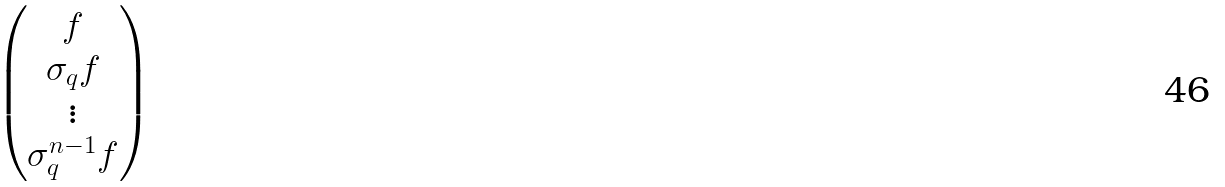Convert formula to latex. <formula><loc_0><loc_0><loc_500><loc_500>\begin{pmatrix} f \\ \sigma _ { q } f \\ \vdots \\ \sigma _ { q } ^ { n - 1 } f \end{pmatrix}</formula> 